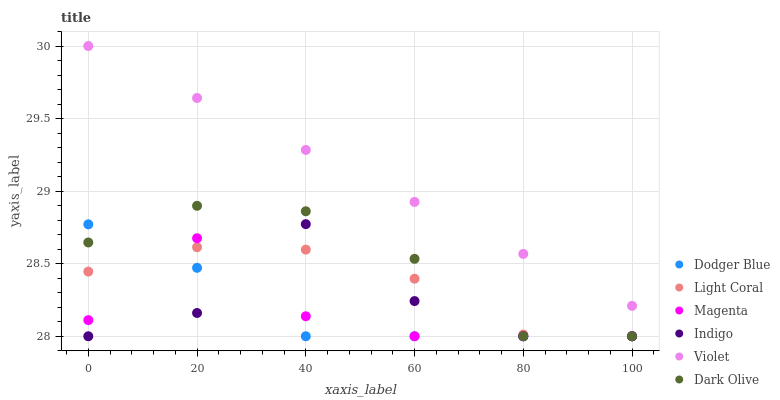Does Dodger Blue have the minimum area under the curve?
Answer yes or no. Yes. Does Violet have the maximum area under the curve?
Answer yes or no. Yes. Does Dark Olive have the minimum area under the curve?
Answer yes or no. No. Does Dark Olive have the maximum area under the curve?
Answer yes or no. No. Is Violet the smoothest?
Answer yes or no. Yes. Is Indigo the roughest?
Answer yes or no. Yes. Is Dark Olive the smoothest?
Answer yes or no. No. Is Dark Olive the roughest?
Answer yes or no. No. Does Indigo have the lowest value?
Answer yes or no. Yes. Does Violet have the lowest value?
Answer yes or no. No. Does Violet have the highest value?
Answer yes or no. Yes. Does Dark Olive have the highest value?
Answer yes or no. No. Is Dark Olive less than Violet?
Answer yes or no. Yes. Is Violet greater than Magenta?
Answer yes or no. Yes. Does Magenta intersect Indigo?
Answer yes or no. Yes. Is Magenta less than Indigo?
Answer yes or no. No. Is Magenta greater than Indigo?
Answer yes or no. No. Does Dark Olive intersect Violet?
Answer yes or no. No. 